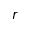Convert formula to latex. <formula><loc_0><loc_0><loc_500><loc_500>r</formula> 